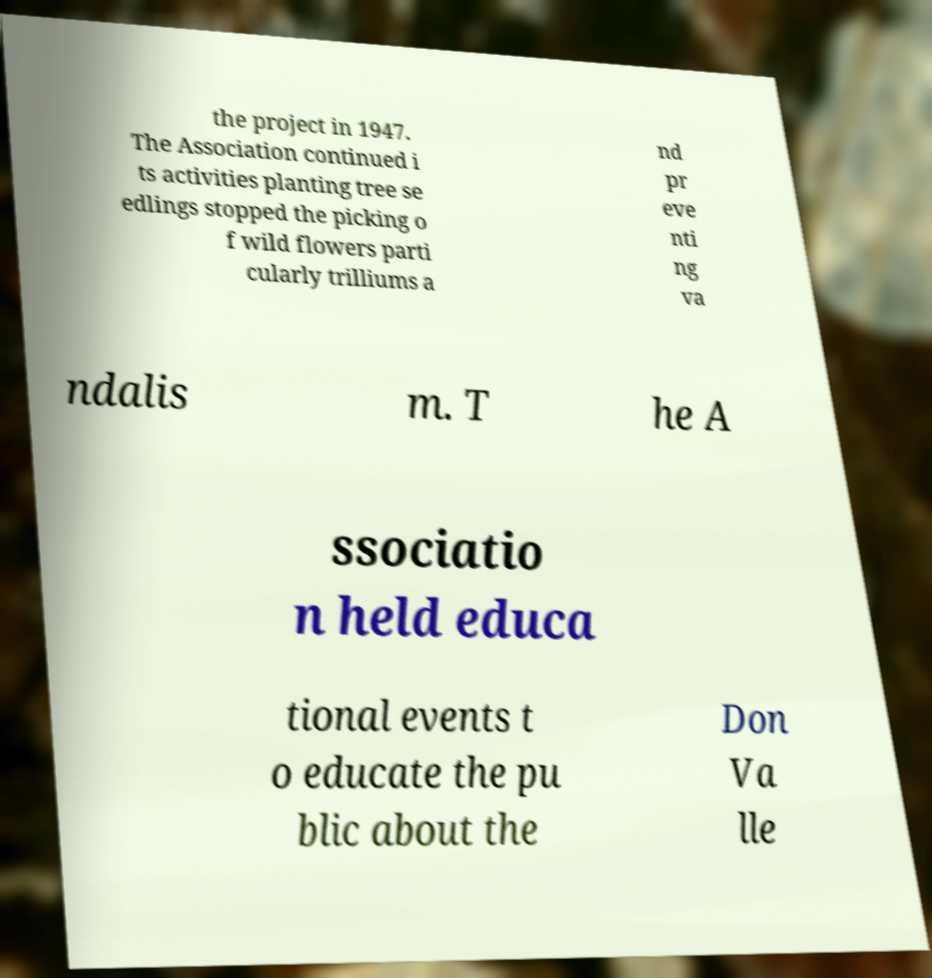Could you extract and type out the text from this image? the project in 1947. The Association continued i ts activities planting tree se edlings stopped the picking o f wild flowers parti cularly trilliums a nd pr eve nti ng va ndalis m. T he A ssociatio n held educa tional events t o educate the pu blic about the Don Va lle 